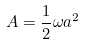Convert formula to latex. <formula><loc_0><loc_0><loc_500><loc_500>A = \frac { 1 } { 2 } \omega a ^ { 2 }</formula> 